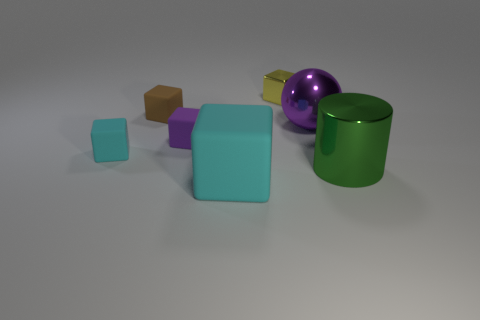Subtract 2 cubes. How many cubes are left? 3 Subtract all cyan cubes. How many cubes are left? 3 Subtract all small yellow blocks. How many blocks are left? 4 Add 1 green shiny objects. How many objects exist? 8 Subtract all red cubes. Subtract all yellow cylinders. How many cubes are left? 5 Subtract all cylinders. How many objects are left? 6 Add 1 big green objects. How many big green objects exist? 2 Subtract 0 green spheres. How many objects are left? 7 Subtract all blue shiny things. Subtract all tiny yellow blocks. How many objects are left? 6 Add 2 tiny cubes. How many tiny cubes are left? 6 